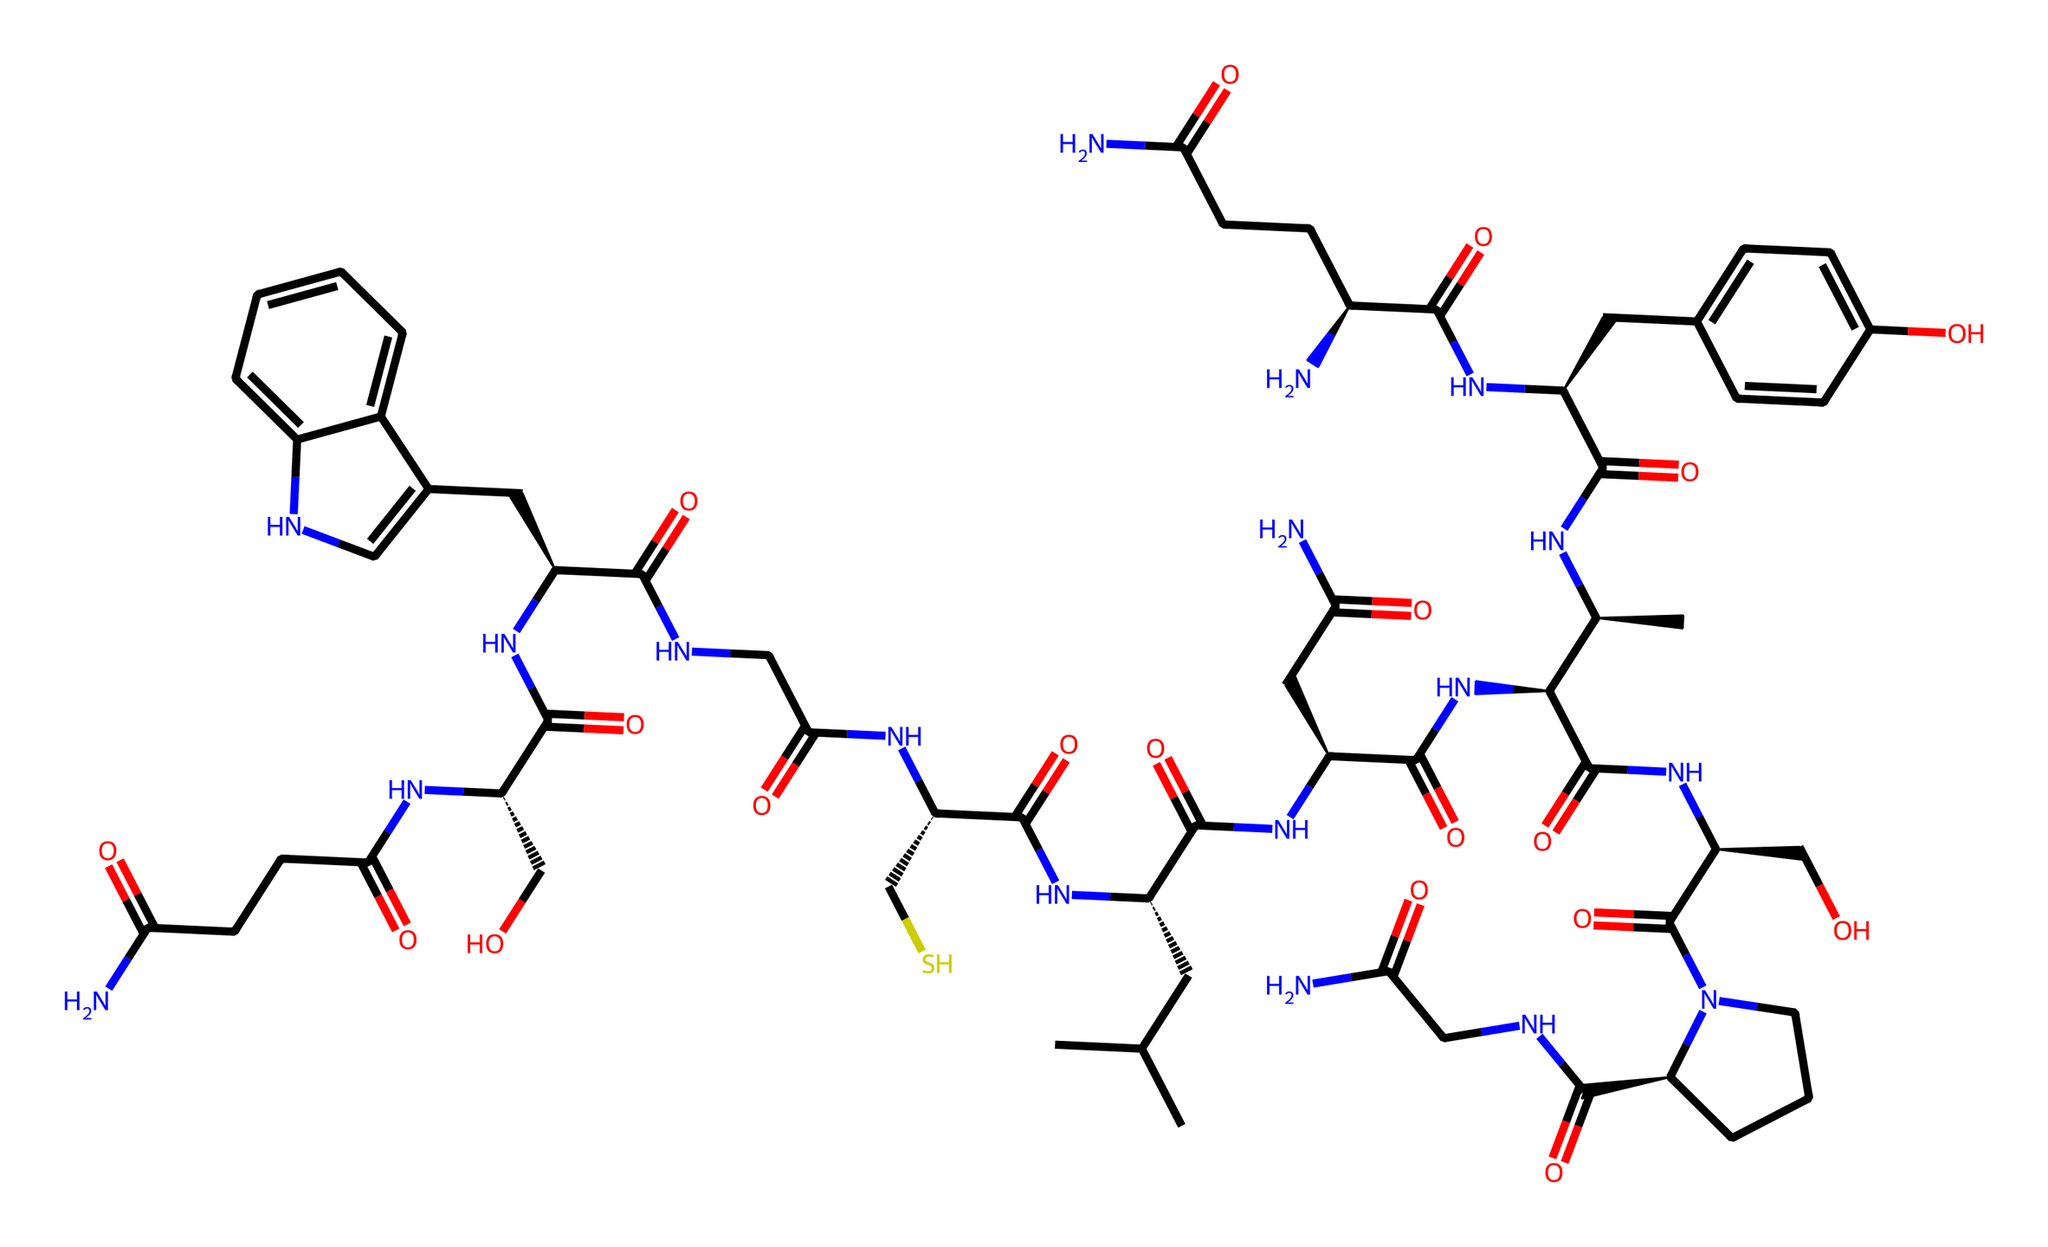What is the molecular formula of oxytocin? To determine the molecular formula from the SMILES representation, we would count the number of each type of atom present in the structure: there are 43 carbon atoms, 66 hydrogen atoms, 10 nitrogen atoms, and 12 oxygen atoms. Therefore, the molecular formula is C43H66N10O12.
Answer: C43H66N10O12 How many chiral centers are in oxytocin? By analyzing the structure, we need to identify the carbon atoms bonded to four different substituents, which define a chiral center. In the provided SMILES, there are three distinct chiral centers present.
Answer: 3 What type of chemical bonding is primarily present in oxytocin? The primary type of bonding present in oxytocin is covalent bonding. This is inferred from the structure where atoms are shown to share electrons, especially carbon, nitrogen, and oxygen forming stable bonds.
Answer: covalent How many amide groups are present in oxytocin? An amide group is characterized by the presence of a carbonyl (C=O) linked to a nitrogen atom (N). From the visual representation in the SMILES, there are five amide groups present in the structure.
Answer: 5 What role does oxytocin play in social bonding? Oxytocin is known as the "bonding hormone" and plays a significant role in enhancing trust and social behaviors among individuals. This is supported by numerous studies showing the correlation between oxytocin levels and social interactions.
Answer: bonding hormone Which functional groups are prominently featured in oxytocin? The prominent functional groups in oxytocin include amides (due to the presence of N-C(=O) connections), as well as alcohols (indicated by hydroxyl groups, -OH). These groups are essential for its biological function and activity.
Answer: amides and alcohols 